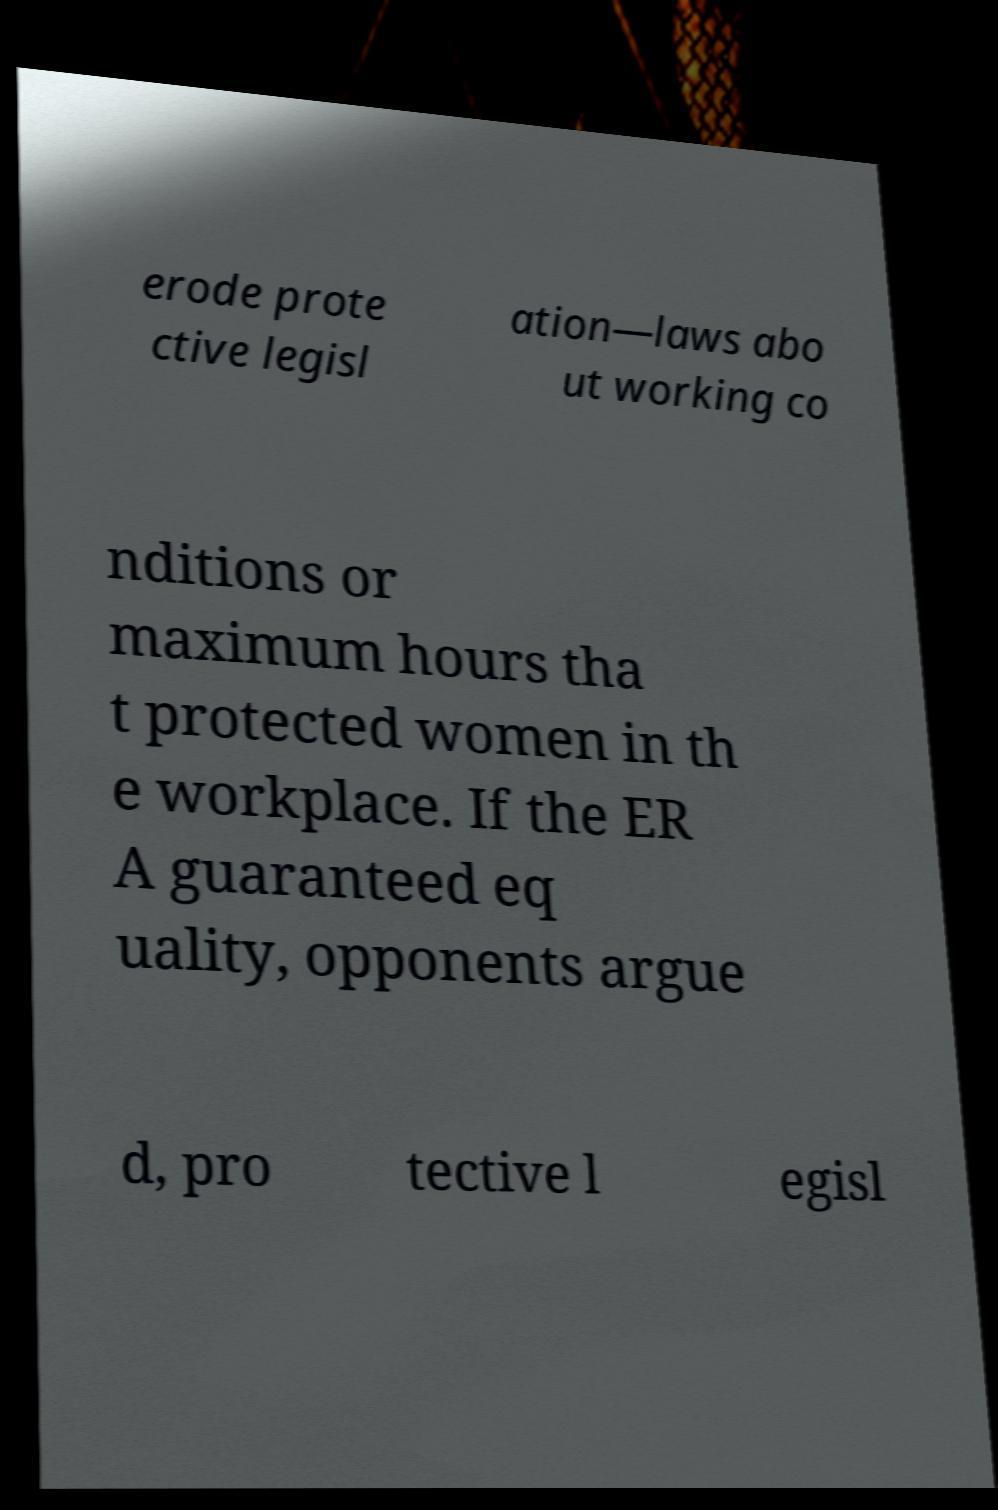Can you accurately transcribe the text from the provided image for me? erode prote ctive legisl ation—laws abo ut working co nditions or maximum hours tha t protected women in th e workplace. If the ER A guaranteed eq uality, opponents argue d, pro tective l egisl 